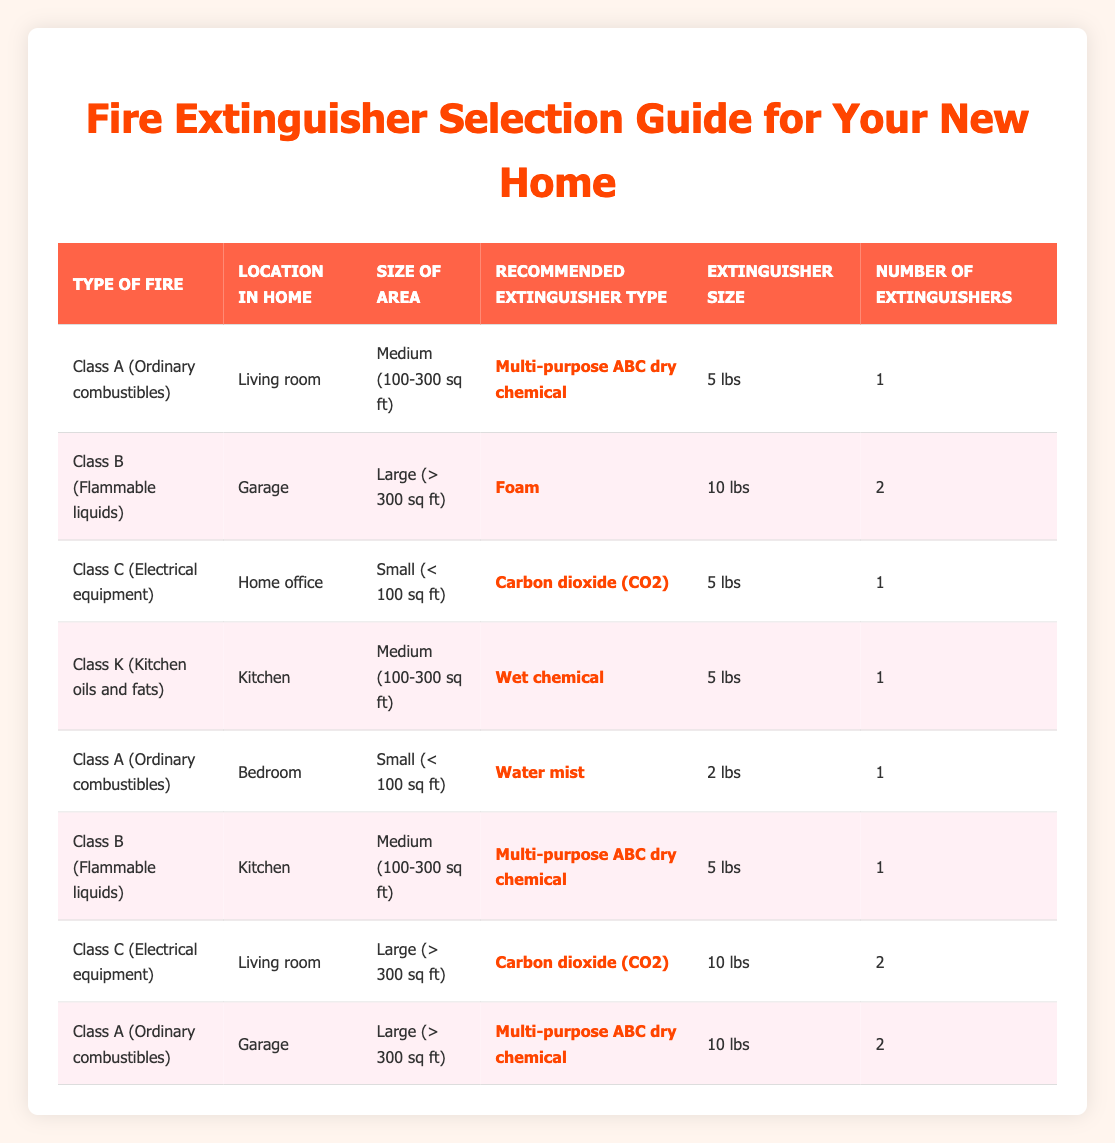What type of extinguisher is recommended for a Class B fire in the garage? According to the table, for a Class B fire (Flammable liquids) in the garage, the recommended extinguisher type is "Foam."
Answer: Foam What is the required size of the extinguisher for a Class C fire in the home office? The table indicates that for a Class C fire (Electrical equipment) in a small area (Home office), the required extinguisher size is "5 lbs."
Answer: 5 lbs How many extinguishers are recommended for a Class A fire in the living room? The table specifies that for a Class A fire (Ordinary combustibles) in a medium-sized living room, only "1" extinguisher is needed.
Answer: 1 Is a 10 lbs extinguisher recommended for a Class C fire in the living room? The table shows that for a Class C fire (Electrical equipment) in a large living room, a "10 lbs" extinguisher is indeed recommended.
Answer: Yes What types of fires require a wet chemical extinguisher? From the table, a wet chemical extinguisher is recommended for Class K fires (Kitchen oils and fats) in the kitchen, according to the specific conditions listed.
Answer: Class K How many total extinguishers are recommended for all Class A fires listed in the table? The table shows two instances of Class A fires: one in the living room (1 extinguisher) and one in the garage (2 extinguishers). Therefore, the total is 1 + 2 = 3.
Answer: 3 Are there more types of extinguishers for large areas than for small areas? The table lists two extinguishers suggested for large areas (Class C in the living room and Class A in the garage), and one for small areas (Class C in the home office) suggesting that "Yes, there are more."
Answer: Yes What is the recommended extinguisher for a Class K fire in a kitchen area of size 100-300 sq ft? The table confirms that for a Class K fire (Kitchen oils and fats) in the kitchen area sized between 100-300 sq ft, the recommended extinguisher type is "Wet chemical."
Answer: Wet chemical 